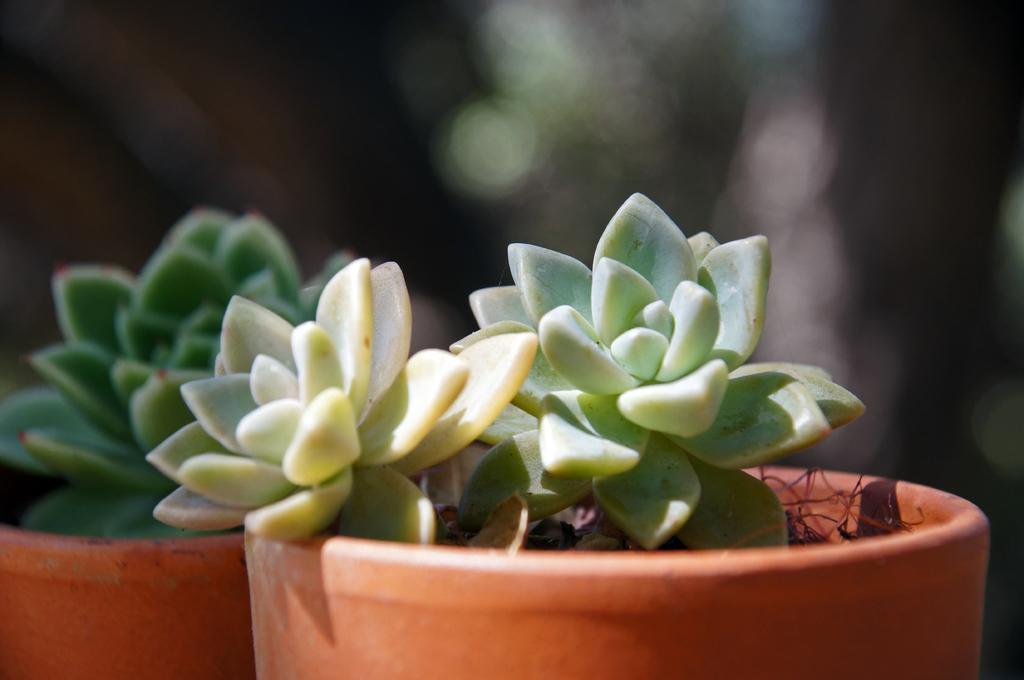In one or two sentences, can you explain what this image depicts? In this image I can see two flower pots which are brown in color and I can see plants which are green in color in them. I can see the blurry background. 